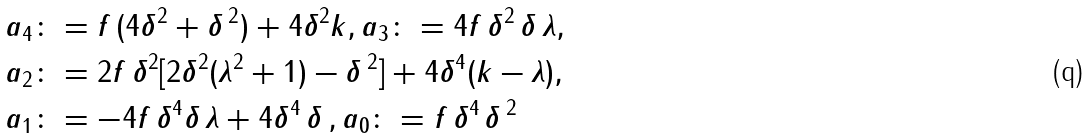<formula> <loc_0><loc_0><loc_500><loc_500>a _ { 4 } & \colon = f \, ( 4 \delta ^ { 2 } + \delta \, ^ { 2 } ) + 4 \delta ^ { 2 } k , a _ { 3 } \colon = 4 f \, \delta ^ { 2 } \, \delta \, \lambda , \\ a _ { 2 } & \colon = 2 f \, \delta ^ { 2 } [ 2 \delta ^ { 2 } ( \lambda ^ { 2 } + 1 ) - \delta \, ^ { 2 } ] + 4 \delta ^ { 4 } ( k - \lambda ) , \\ a _ { 1 } & \colon = - 4 f \, \delta ^ { 4 } \delta \, \lambda + 4 \delta ^ { 4 } \, \delta \, , a _ { 0 } \colon = f \, \delta ^ { 4 \, } \delta \, ^ { 2 }</formula> 